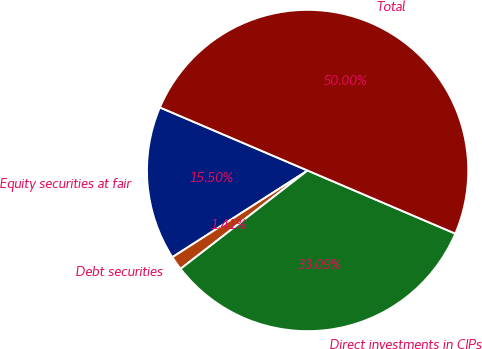Convert chart to OTSL. <chart><loc_0><loc_0><loc_500><loc_500><pie_chart><fcel>Equity securities at fair<fcel>Debt securities<fcel>Direct investments in CIPs<fcel>Total<nl><fcel>15.5%<fcel>1.41%<fcel>33.09%<fcel>50.0%<nl></chart> 